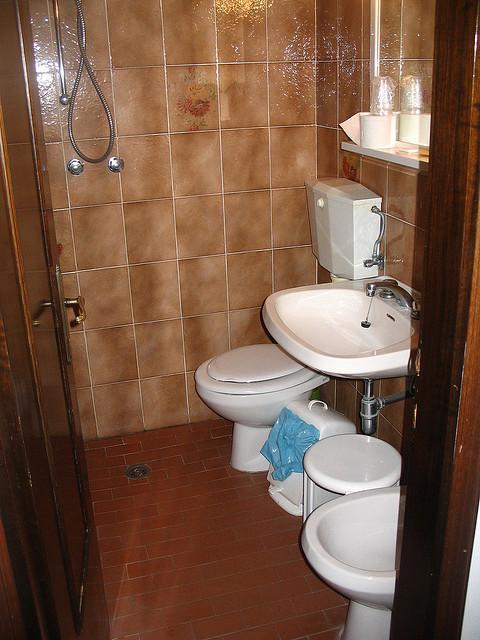How many toilets are in the picture?
Give a very brief answer. 2. 